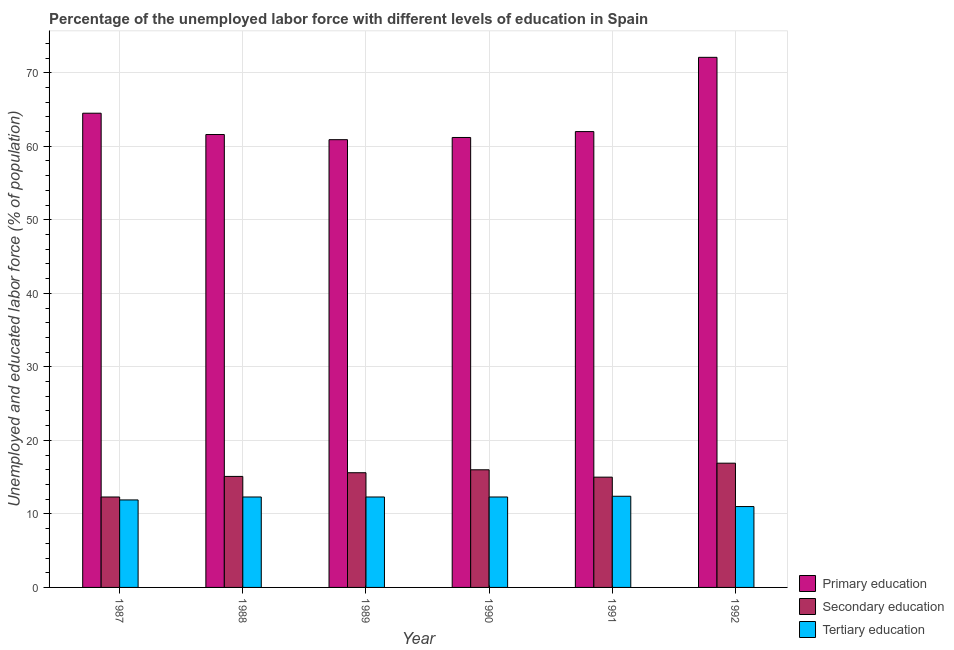How many different coloured bars are there?
Your answer should be very brief. 3. Are the number of bars per tick equal to the number of legend labels?
Your answer should be compact. Yes. Are the number of bars on each tick of the X-axis equal?
Your response must be concise. Yes. What is the label of the 4th group of bars from the left?
Make the answer very short. 1990. In how many cases, is the number of bars for a given year not equal to the number of legend labels?
Provide a short and direct response. 0. What is the percentage of labor force who received secondary education in 1989?
Your answer should be compact. 15.6. Across all years, what is the maximum percentage of labor force who received primary education?
Offer a terse response. 72.1. What is the total percentage of labor force who received primary education in the graph?
Keep it short and to the point. 382.3. What is the difference between the percentage of labor force who received primary education in 1991 and that in 1992?
Your answer should be very brief. -10.1. What is the difference between the percentage of labor force who received tertiary education in 1987 and the percentage of labor force who received secondary education in 1991?
Offer a very short reply. -0.5. What is the average percentage of labor force who received primary education per year?
Ensure brevity in your answer.  63.72. What is the ratio of the percentage of labor force who received secondary education in 1988 to that in 1990?
Give a very brief answer. 0.94. Is the percentage of labor force who received secondary education in 1991 less than that in 1992?
Your answer should be very brief. Yes. What is the difference between the highest and the second highest percentage of labor force who received secondary education?
Keep it short and to the point. 0.9. What is the difference between the highest and the lowest percentage of labor force who received secondary education?
Offer a terse response. 4.6. Is the sum of the percentage of labor force who received primary education in 1988 and 1992 greater than the maximum percentage of labor force who received secondary education across all years?
Keep it short and to the point. Yes. What does the 2nd bar from the left in 1988 represents?
Your response must be concise. Secondary education. What does the 1st bar from the right in 1988 represents?
Your answer should be very brief. Tertiary education. How many bars are there?
Offer a very short reply. 18. How many years are there in the graph?
Keep it short and to the point. 6. Does the graph contain any zero values?
Provide a short and direct response. No. How are the legend labels stacked?
Ensure brevity in your answer.  Vertical. What is the title of the graph?
Your answer should be very brief. Percentage of the unemployed labor force with different levels of education in Spain. What is the label or title of the Y-axis?
Ensure brevity in your answer.  Unemployed and educated labor force (% of population). What is the Unemployed and educated labor force (% of population) of Primary education in 1987?
Give a very brief answer. 64.5. What is the Unemployed and educated labor force (% of population) in Secondary education in 1987?
Make the answer very short. 12.3. What is the Unemployed and educated labor force (% of population) in Tertiary education in 1987?
Keep it short and to the point. 11.9. What is the Unemployed and educated labor force (% of population) in Primary education in 1988?
Offer a terse response. 61.6. What is the Unemployed and educated labor force (% of population) in Secondary education in 1988?
Offer a very short reply. 15.1. What is the Unemployed and educated labor force (% of population) in Tertiary education in 1988?
Ensure brevity in your answer.  12.3. What is the Unemployed and educated labor force (% of population) of Primary education in 1989?
Your answer should be very brief. 60.9. What is the Unemployed and educated labor force (% of population) of Secondary education in 1989?
Your answer should be very brief. 15.6. What is the Unemployed and educated labor force (% of population) in Tertiary education in 1989?
Offer a terse response. 12.3. What is the Unemployed and educated labor force (% of population) in Primary education in 1990?
Provide a short and direct response. 61.2. What is the Unemployed and educated labor force (% of population) of Secondary education in 1990?
Provide a succinct answer. 16. What is the Unemployed and educated labor force (% of population) of Tertiary education in 1990?
Keep it short and to the point. 12.3. What is the Unemployed and educated labor force (% of population) in Secondary education in 1991?
Offer a terse response. 15. What is the Unemployed and educated labor force (% of population) in Tertiary education in 1991?
Offer a very short reply. 12.4. What is the Unemployed and educated labor force (% of population) of Primary education in 1992?
Keep it short and to the point. 72.1. What is the Unemployed and educated labor force (% of population) in Secondary education in 1992?
Provide a short and direct response. 16.9. Across all years, what is the maximum Unemployed and educated labor force (% of population) of Primary education?
Your answer should be compact. 72.1. Across all years, what is the maximum Unemployed and educated labor force (% of population) in Secondary education?
Provide a short and direct response. 16.9. Across all years, what is the maximum Unemployed and educated labor force (% of population) of Tertiary education?
Offer a terse response. 12.4. Across all years, what is the minimum Unemployed and educated labor force (% of population) in Primary education?
Your answer should be compact. 60.9. Across all years, what is the minimum Unemployed and educated labor force (% of population) of Secondary education?
Your answer should be very brief. 12.3. Across all years, what is the minimum Unemployed and educated labor force (% of population) in Tertiary education?
Provide a succinct answer. 11. What is the total Unemployed and educated labor force (% of population) in Primary education in the graph?
Make the answer very short. 382.3. What is the total Unemployed and educated labor force (% of population) in Secondary education in the graph?
Provide a succinct answer. 90.9. What is the total Unemployed and educated labor force (% of population) of Tertiary education in the graph?
Ensure brevity in your answer.  72.2. What is the difference between the Unemployed and educated labor force (% of population) of Tertiary education in 1987 and that in 1988?
Offer a terse response. -0.4. What is the difference between the Unemployed and educated labor force (% of population) of Secondary education in 1987 and that in 1990?
Ensure brevity in your answer.  -3.7. What is the difference between the Unemployed and educated labor force (% of population) in Tertiary education in 1987 and that in 1990?
Your answer should be compact. -0.4. What is the difference between the Unemployed and educated labor force (% of population) in Primary education in 1987 and that in 1991?
Your answer should be very brief. 2.5. What is the difference between the Unemployed and educated labor force (% of population) in Tertiary education in 1987 and that in 1992?
Ensure brevity in your answer.  0.9. What is the difference between the Unemployed and educated labor force (% of population) in Primary education in 1988 and that in 1989?
Your answer should be compact. 0.7. What is the difference between the Unemployed and educated labor force (% of population) in Secondary education in 1988 and that in 1989?
Your answer should be compact. -0.5. What is the difference between the Unemployed and educated labor force (% of population) of Secondary education in 1988 and that in 1990?
Keep it short and to the point. -0.9. What is the difference between the Unemployed and educated labor force (% of population) in Tertiary education in 1988 and that in 1990?
Provide a short and direct response. 0. What is the difference between the Unemployed and educated labor force (% of population) in Secondary education in 1988 and that in 1991?
Make the answer very short. 0.1. What is the difference between the Unemployed and educated labor force (% of population) of Primary education in 1988 and that in 1992?
Provide a short and direct response. -10.5. What is the difference between the Unemployed and educated labor force (% of population) in Tertiary education in 1988 and that in 1992?
Ensure brevity in your answer.  1.3. What is the difference between the Unemployed and educated labor force (% of population) in Secondary education in 1989 and that in 1990?
Give a very brief answer. -0.4. What is the difference between the Unemployed and educated labor force (% of population) of Tertiary education in 1989 and that in 1991?
Provide a succinct answer. -0.1. What is the difference between the Unemployed and educated labor force (% of population) in Primary education in 1989 and that in 1992?
Your response must be concise. -11.2. What is the difference between the Unemployed and educated labor force (% of population) in Tertiary education in 1989 and that in 1992?
Offer a terse response. 1.3. What is the difference between the Unemployed and educated labor force (% of population) of Primary education in 1990 and that in 1991?
Your answer should be very brief. -0.8. What is the difference between the Unemployed and educated labor force (% of population) of Tertiary education in 1990 and that in 1991?
Provide a succinct answer. -0.1. What is the difference between the Unemployed and educated labor force (% of population) of Tertiary education in 1991 and that in 1992?
Give a very brief answer. 1.4. What is the difference between the Unemployed and educated labor force (% of population) in Primary education in 1987 and the Unemployed and educated labor force (% of population) in Secondary education in 1988?
Give a very brief answer. 49.4. What is the difference between the Unemployed and educated labor force (% of population) of Primary education in 1987 and the Unemployed and educated labor force (% of population) of Tertiary education in 1988?
Give a very brief answer. 52.2. What is the difference between the Unemployed and educated labor force (% of population) of Primary education in 1987 and the Unemployed and educated labor force (% of population) of Secondary education in 1989?
Give a very brief answer. 48.9. What is the difference between the Unemployed and educated labor force (% of population) of Primary education in 1987 and the Unemployed and educated labor force (% of population) of Tertiary education in 1989?
Offer a very short reply. 52.2. What is the difference between the Unemployed and educated labor force (% of population) in Secondary education in 1987 and the Unemployed and educated labor force (% of population) in Tertiary education in 1989?
Offer a very short reply. 0. What is the difference between the Unemployed and educated labor force (% of population) in Primary education in 1987 and the Unemployed and educated labor force (% of population) in Secondary education in 1990?
Provide a succinct answer. 48.5. What is the difference between the Unemployed and educated labor force (% of population) in Primary education in 1987 and the Unemployed and educated labor force (% of population) in Tertiary education in 1990?
Make the answer very short. 52.2. What is the difference between the Unemployed and educated labor force (% of population) of Secondary education in 1987 and the Unemployed and educated labor force (% of population) of Tertiary education in 1990?
Your answer should be very brief. 0. What is the difference between the Unemployed and educated labor force (% of population) of Primary education in 1987 and the Unemployed and educated labor force (% of population) of Secondary education in 1991?
Your response must be concise. 49.5. What is the difference between the Unemployed and educated labor force (% of population) of Primary education in 1987 and the Unemployed and educated labor force (% of population) of Tertiary education in 1991?
Provide a short and direct response. 52.1. What is the difference between the Unemployed and educated labor force (% of population) of Secondary education in 1987 and the Unemployed and educated labor force (% of population) of Tertiary education in 1991?
Make the answer very short. -0.1. What is the difference between the Unemployed and educated labor force (% of population) in Primary education in 1987 and the Unemployed and educated labor force (% of population) in Secondary education in 1992?
Provide a succinct answer. 47.6. What is the difference between the Unemployed and educated labor force (% of population) of Primary education in 1987 and the Unemployed and educated labor force (% of population) of Tertiary education in 1992?
Make the answer very short. 53.5. What is the difference between the Unemployed and educated labor force (% of population) in Primary education in 1988 and the Unemployed and educated labor force (% of population) in Secondary education in 1989?
Your response must be concise. 46. What is the difference between the Unemployed and educated labor force (% of population) of Primary education in 1988 and the Unemployed and educated labor force (% of population) of Tertiary education in 1989?
Your answer should be very brief. 49.3. What is the difference between the Unemployed and educated labor force (% of population) in Primary education in 1988 and the Unemployed and educated labor force (% of population) in Secondary education in 1990?
Provide a succinct answer. 45.6. What is the difference between the Unemployed and educated labor force (% of population) of Primary education in 1988 and the Unemployed and educated labor force (% of population) of Tertiary education in 1990?
Provide a short and direct response. 49.3. What is the difference between the Unemployed and educated labor force (% of population) of Secondary education in 1988 and the Unemployed and educated labor force (% of population) of Tertiary education in 1990?
Provide a succinct answer. 2.8. What is the difference between the Unemployed and educated labor force (% of population) in Primary education in 1988 and the Unemployed and educated labor force (% of population) in Secondary education in 1991?
Offer a very short reply. 46.6. What is the difference between the Unemployed and educated labor force (% of population) in Primary education in 1988 and the Unemployed and educated labor force (% of population) in Tertiary education in 1991?
Your answer should be compact. 49.2. What is the difference between the Unemployed and educated labor force (% of population) in Primary education in 1988 and the Unemployed and educated labor force (% of population) in Secondary education in 1992?
Offer a very short reply. 44.7. What is the difference between the Unemployed and educated labor force (% of population) of Primary education in 1988 and the Unemployed and educated labor force (% of population) of Tertiary education in 1992?
Your answer should be very brief. 50.6. What is the difference between the Unemployed and educated labor force (% of population) of Secondary education in 1988 and the Unemployed and educated labor force (% of population) of Tertiary education in 1992?
Ensure brevity in your answer.  4.1. What is the difference between the Unemployed and educated labor force (% of population) of Primary education in 1989 and the Unemployed and educated labor force (% of population) of Secondary education in 1990?
Ensure brevity in your answer.  44.9. What is the difference between the Unemployed and educated labor force (% of population) in Primary education in 1989 and the Unemployed and educated labor force (% of population) in Tertiary education in 1990?
Your answer should be very brief. 48.6. What is the difference between the Unemployed and educated labor force (% of population) in Primary education in 1989 and the Unemployed and educated labor force (% of population) in Secondary education in 1991?
Provide a succinct answer. 45.9. What is the difference between the Unemployed and educated labor force (% of population) in Primary education in 1989 and the Unemployed and educated labor force (% of population) in Tertiary education in 1991?
Provide a succinct answer. 48.5. What is the difference between the Unemployed and educated labor force (% of population) of Primary education in 1989 and the Unemployed and educated labor force (% of population) of Secondary education in 1992?
Your answer should be compact. 44. What is the difference between the Unemployed and educated labor force (% of population) of Primary education in 1989 and the Unemployed and educated labor force (% of population) of Tertiary education in 1992?
Give a very brief answer. 49.9. What is the difference between the Unemployed and educated labor force (% of population) in Secondary education in 1989 and the Unemployed and educated labor force (% of population) in Tertiary education in 1992?
Offer a terse response. 4.6. What is the difference between the Unemployed and educated labor force (% of population) in Primary education in 1990 and the Unemployed and educated labor force (% of population) in Secondary education in 1991?
Offer a terse response. 46.2. What is the difference between the Unemployed and educated labor force (% of population) in Primary education in 1990 and the Unemployed and educated labor force (% of population) in Tertiary education in 1991?
Provide a short and direct response. 48.8. What is the difference between the Unemployed and educated labor force (% of population) in Secondary education in 1990 and the Unemployed and educated labor force (% of population) in Tertiary education in 1991?
Offer a very short reply. 3.6. What is the difference between the Unemployed and educated labor force (% of population) in Primary education in 1990 and the Unemployed and educated labor force (% of population) in Secondary education in 1992?
Offer a terse response. 44.3. What is the difference between the Unemployed and educated labor force (% of population) in Primary education in 1990 and the Unemployed and educated labor force (% of population) in Tertiary education in 1992?
Ensure brevity in your answer.  50.2. What is the difference between the Unemployed and educated labor force (% of population) in Primary education in 1991 and the Unemployed and educated labor force (% of population) in Secondary education in 1992?
Your response must be concise. 45.1. What is the difference between the Unemployed and educated labor force (% of population) of Primary education in 1991 and the Unemployed and educated labor force (% of population) of Tertiary education in 1992?
Your response must be concise. 51. What is the average Unemployed and educated labor force (% of population) in Primary education per year?
Make the answer very short. 63.72. What is the average Unemployed and educated labor force (% of population) in Secondary education per year?
Your answer should be very brief. 15.15. What is the average Unemployed and educated labor force (% of population) of Tertiary education per year?
Keep it short and to the point. 12.03. In the year 1987, what is the difference between the Unemployed and educated labor force (% of population) of Primary education and Unemployed and educated labor force (% of population) of Secondary education?
Your answer should be compact. 52.2. In the year 1987, what is the difference between the Unemployed and educated labor force (% of population) of Primary education and Unemployed and educated labor force (% of population) of Tertiary education?
Provide a succinct answer. 52.6. In the year 1988, what is the difference between the Unemployed and educated labor force (% of population) of Primary education and Unemployed and educated labor force (% of population) of Secondary education?
Your answer should be compact. 46.5. In the year 1988, what is the difference between the Unemployed and educated labor force (% of population) of Primary education and Unemployed and educated labor force (% of population) of Tertiary education?
Give a very brief answer. 49.3. In the year 1989, what is the difference between the Unemployed and educated labor force (% of population) in Primary education and Unemployed and educated labor force (% of population) in Secondary education?
Your response must be concise. 45.3. In the year 1989, what is the difference between the Unemployed and educated labor force (% of population) of Primary education and Unemployed and educated labor force (% of population) of Tertiary education?
Your answer should be compact. 48.6. In the year 1990, what is the difference between the Unemployed and educated labor force (% of population) of Primary education and Unemployed and educated labor force (% of population) of Secondary education?
Make the answer very short. 45.2. In the year 1990, what is the difference between the Unemployed and educated labor force (% of population) of Primary education and Unemployed and educated labor force (% of population) of Tertiary education?
Your response must be concise. 48.9. In the year 1991, what is the difference between the Unemployed and educated labor force (% of population) of Primary education and Unemployed and educated labor force (% of population) of Tertiary education?
Provide a short and direct response. 49.6. In the year 1992, what is the difference between the Unemployed and educated labor force (% of population) in Primary education and Unemployed and educated labor force (% of population) in Secondary education?
Give a very brief answer. 55.2. In the year 1992, what is the difference between the Unemployed and educated labor force (% of population) in Primary education and Unemployed and educated labor force (% of population) in Tertiary education?
Offer a very short reply. 61.1. What is the ratio of the Unemployed and educated labor force (% of population) in Primary education in 1987 to that in 1988?
Give a very brief answer. 1.05. What is the ratio of the Unemployed and educated labor force (% of population) in Secondary education in 1987 to that in 1988?
Your response must be concise. 0.81. What is the ratio of the Unemployed and educated labor force (% of population) of Tertiary education in 1987 to that in 1988?
Your answer should be very brief. 0.97. What is the ratio of the Unemployed and educated labor force (% of population) of Primary education in 1987 to that in 1989?
Offer a very short reply. 1.06. What is the ratio of the Unemployed and educated labor force (% of population) in Secondary education in 1987 to that in 1989?
Your response must be concise. 0.79. What is the ratio of the Unemployed and educated labor force (% of population) in Tertiary education in 1987 to that in 1989?
Ensure brevity in your answer.  0.97. What is the ratio of the Unemployed and educated labor force (% of population) in Primary education in 1987 to that in 1990?
Give a very brief answer. 1.05. What is the ratio of the Unemployed and educated labor force (% of population) in Secondary education in 1987 to that in 1990?
Provide a short and direct response. 0.77. What is the ratio of the Unemployed and educated labor force (% of population) in Tertiary education in 1987 to that in 1990?
Give a very brief answer. 0.97. What is the ratio of the Unemployed and educated labor force (% of population) of Primary education in 1987 to that in 1991?
Make the answer very short. 1.04. What is the ratio of the Unemployed and educated labor force (% of population) in Secondary education in 1987 to that in 1991?
Give a very brief answer. 0.82. What is the ratio of the Unemployed and educated labor force (% of population) of Tertiary education in 1987 to that in 1991?
Make the answer very short. 0.96. What is the ratio of the Unemployed and educated labor force (% of population) of Primary education in 1987 to that in 1992?
Your answer should be very brief. 0.89. What is the ratio of the Unemployed and educated labor force (% of population) of Secondary education in 1987 to that in 1992?
Your answer should be compact. 0.73. What is the ratio of the Unemployed and educated labor force (% of population) of Tertiary education in 1987 to that in 1992?
Your answer should be very brief. 1.08. What is the ratio of the Unemployed and educated labor force (% of population) of Primary education in 1988 to that in 1989?
Your answer should be compact. 1.01. What is the ratio of the Unemployed and educated labor force (% of population) of Secondary education in 1988 to that in 1989?
Make the answer very short. 0.97. What is the ratio of the Unemployed and educated labor force (% of population) in Secondary education in 1988 to that in 1990?
Your answer should be compact. 0.94. What is the ratio of the Unemployed and educated labor force (% of population) in Tertiary education in 1988 to that in 1990?
Provide a succinct answer. 1. What is the ratio of the Unemployed and educated labor force (% of population) in Primary education in 1988 to that in 1991?
Keep it short and to the point. 0.99. What is the ratio of the Unemployed and educated labor force (% of population) of Secondary education in 1988 to that in 1991?
Provide a succinct answer. 1.01. What is the ratio of the Unemployed and educated labor force (% of population) in Tertiary education in 1988 to that in 1991?
Give a very brief answer. 0.99. What is the ratio of the Unemployed and educated labor force (% of population) in Primary education in 1988 to that in 1992?
Your answer should be very brief. 0.85. What is the ratio of the Unemployed and educated labor force (% of population) of Secondary education in 1988 to that in 1992?
Make the answer very short. 0.89. What is the ratio of the Unemployed and educated labor force (% of population) in Tertiary education in 1988 to that in 1992?
Offer a terse response. 1.12. What is the ratio of the Unemployed and educated labor force (% of population) in Secondary education in 1989 to that in 1990?
Keep it short and to the point. 0.97. What is the ratio of the Unemployed and educated labor force (% of population) in Tertiary education in 1989 to that in 1990?
Offer a terse response. 1. What is the ratio of the Unemployed and educated labor force (% of population) in Primary education in 1989 to that in 1991?
Provide a short and direct response. 0.98. What is the ratio of the Unemployed and educated labor force (% of population) in Secondary education in 1989 to that in 1991?
Offer a terse response. 1.04. What is the ratio of the Unemployed and educated labor force (% of population) of Primary education in 1989 to that in 1992?
Keep it short and to the point. 0.84. What is the ratio of the Unemployed and educated labor force (% of population) in Tertiary education in 1989 to that in 1992?
Offer a very short reply. 1.12. What is the ratio of the Unemployed and educated labor force (% of population) in Primary education in 1990 to that in 1991?
Your answer should be very brief. 0.99. What is the ratio of the Unemployed and educated labor force (% of population) of Secondary education in 1990 to that in 1991?
Ensure brevity in your answer.  1.07. What is the ratio of the Unemployed and educated labor force (% of population) of Primary education in 1990 to that in 1992?
Make the answer very short. 0.85. What is the ratio of the Unemployed and educated labor force (% of population) in Secondary education in 1990 to that in 1992?
Provide a short and direct response. 0.95. What is the ratio of the Unemployed and educated labor force (% of population) of Tertiary education in 1990 to that in 1992?
Your answer should be very brief. 1.12. What is the ratio of the Unemployed and educated labor force (% of population) in Primary education in 1991 to that in 1992?
Provide a succinct answer. 0.86. What is the ratio of the Unemployed and educated labor force (% of population) of Secondary education in 1991 to that in 1992?
Your answer should be compact. 0.89. What is the ratio of the Unemployed and educated labor force (% of population) in Tertiary education in 1991 to that in 1992?
Your answer should be very brief. 1.13. What is the difference between the highest and the second highest Unemployed and educated labor force (% of population) in Primary education?
Provide a succinct answer. 7.6. What is the difference between the highest and the second highest Unemployed and educated labor force (% of population) of Secondary education?
Provide a succinct answer. 0.9. What is the difference between the highest and the second highest Unemployed and educated labor force (% of population) of Tertiary education?
Offer a very short reply. 0.1. What is the difference between the highest and the lowest Unemployed and educated labor force (% of population) of Tertiary education?
Keep it short and to the point. 1.4. 